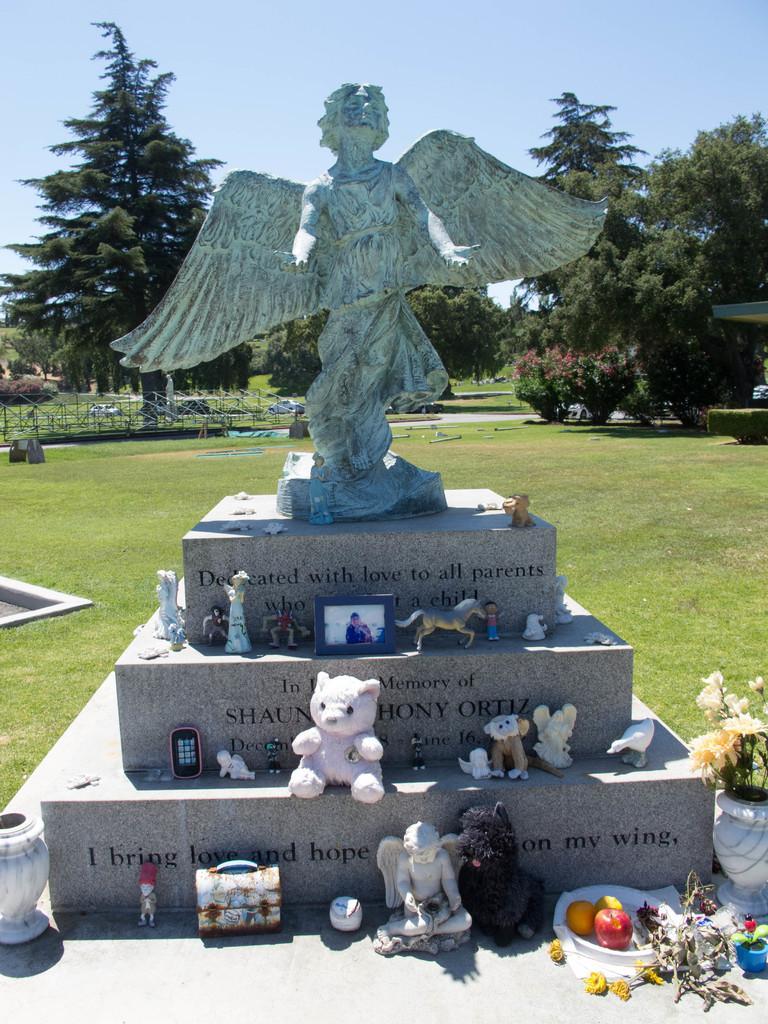How would you summarize this image in a sentence or two? In the center of the image we can see a statue and there are many toys, photo frames, mobile, bag and some objects placed on the pedestal. In the background there is a fence, trees and sky. 